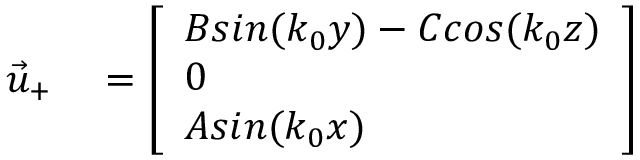Convert formula to latex. <formula><loc_0><loc_0><loc_500><loc_500>\begin{array} { r l } { \vec { u } _ { + } } & = \left [ \begin{array} { l } { B \sin ( k _ { 0 } y ) - C \cos ( k _ { 0 } z ) } \\ { 0 } \\ { A \sin ( k _ { 0 } x ) } \end{array} \right ] } \end{array}</formula> 